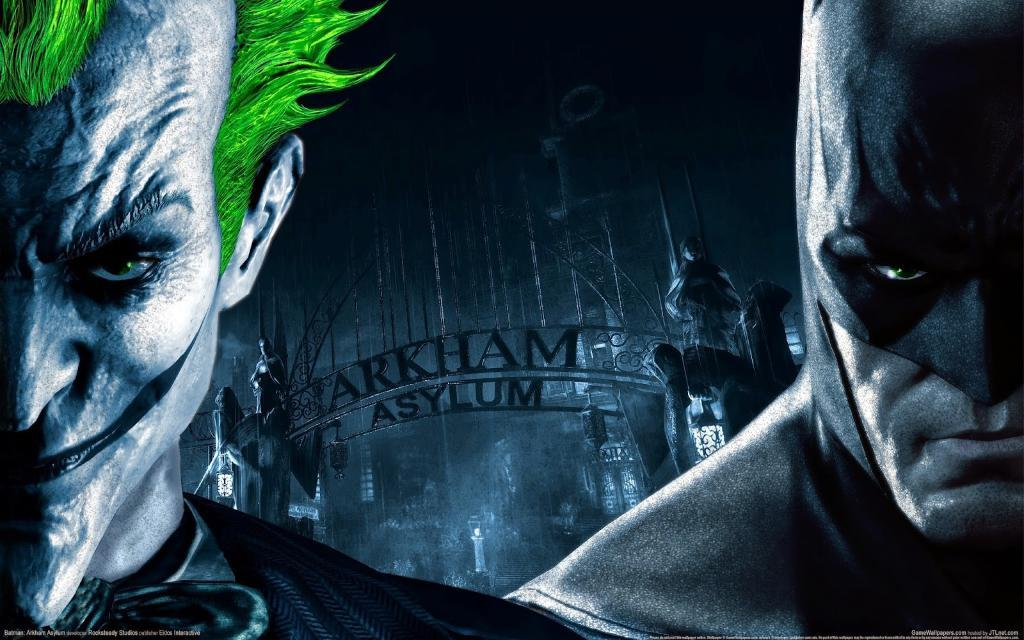How many people are in the image? There are two persons in the image. What else can be seen in the image besides the people? There are sculptures, lights, an arch, and text at the bottom of the image. What type of pump is being used by the queen in the image? There is no queen or pump present in the image. How does the image start, and what is the first thing seen? The image does not have a start or a specific order in which elements are seen; it is a static representation. 